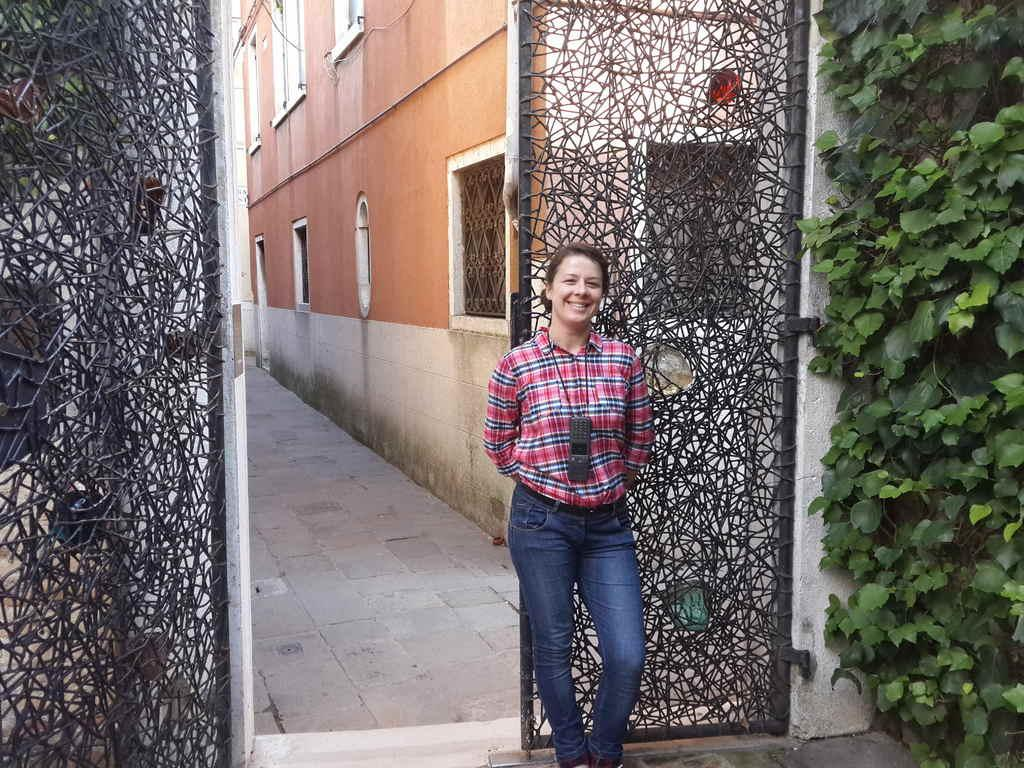What is the main subject of the image? There is a beautiful girl standing in the middle of the image. Can you describe what the girl is wearing? The girl is wearing a shirt and trousers. What can be seen behind the girl in the image? There is an iron gate behind the girl. What type of vegetation is on the right side of the image? There are plants on the right side of the image. What type of structure is depicted in the image? The image depicts a building. What type of punishment is the girl receiving in the image? There is no indication of punishment in the image; the girl is simply standing in the middle of the image. How many hands does the girl have in the image? The image does not show the girl's hands, so it is impossible to determine the number of hands she has. 